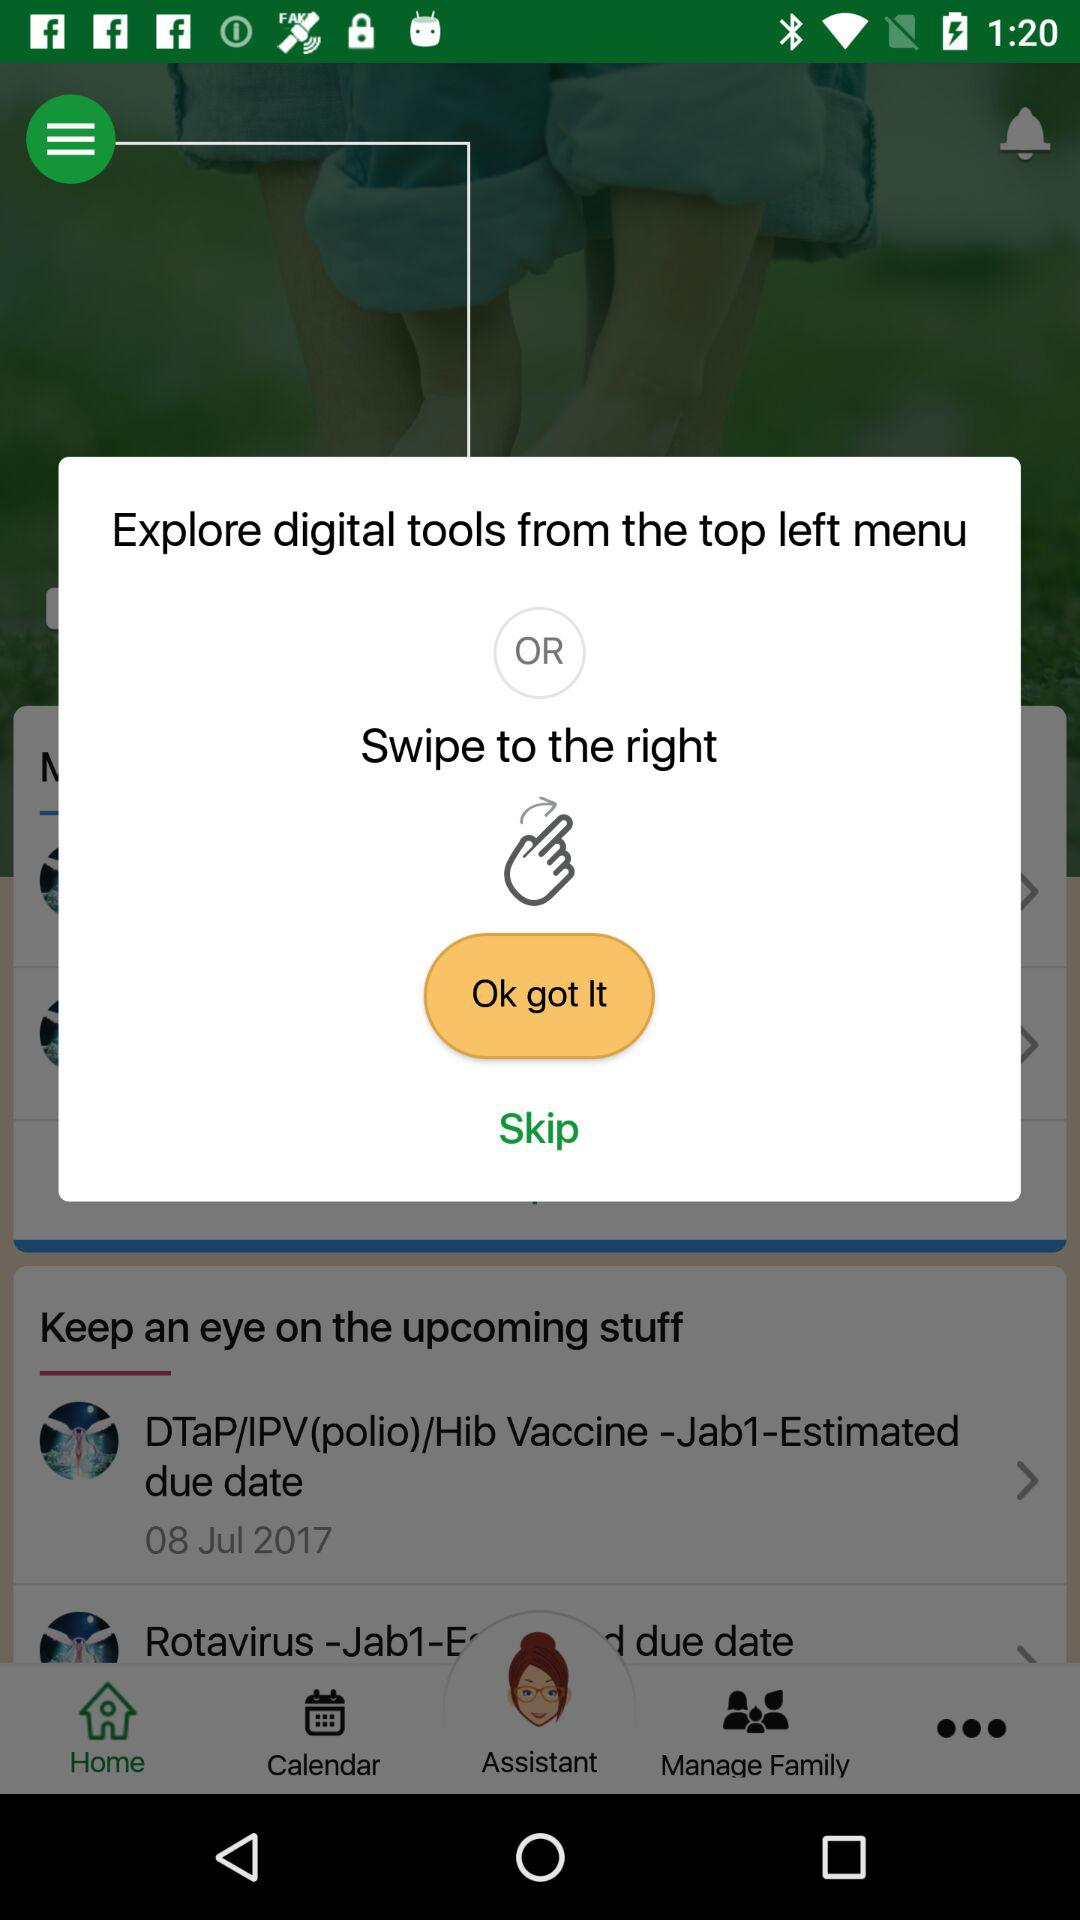What is the selected tab? The selected tab is "Home". 